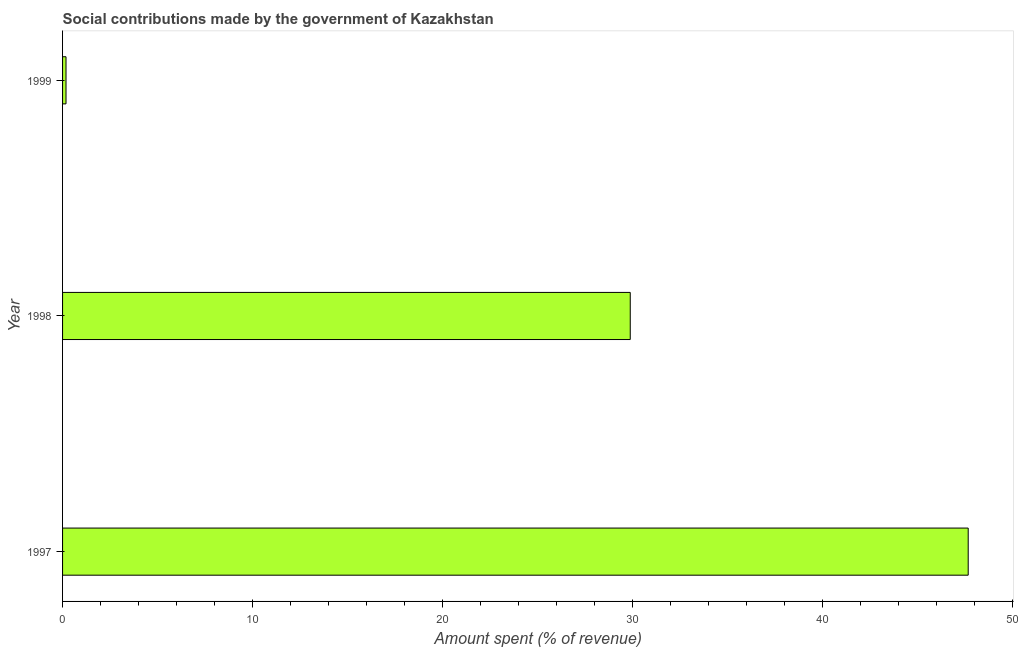Does the graph contain grids?
Make the answer very short. No. What is the title of the graph?
Your response must be concise. Social contributions made by the government of Kazakhstan. What is the label or title of the X-axis?
Ensure brevity in your answer.  Amount spent (% of revenue). What is the amount spent in making social contributions in 1998?
Give a very brief answer. 29.88. Across all years, what is the maximum amount spent in making social contributions?
Your answer should be compact. 47.67. Across all years, what is the minimum amount spent in making social contributions?
Your answer should be very brief. 0.18. In which year was the amount spent in making social contributions maximum?
Your answer should be compact. 1997. In which year was the amount spent in making social contributions minimum?
Give a very brief answer. 1999. What is the sum of the amount spent in making social contributions?
Give a very brief answer. 77.74. What is the difference between the amount spent in making social contributions in 1998 and 1999?
Provide a short and direct response. 29.7. What is the average amount spent in making social contributions per year?
Make the answer very short. 25.91. What is the median amount spent in making social contributions?
Give a very brief answer. 29.88. What is the ratio of the amount spent in making social contributions in 1997 to that in 1999?
Provide a short and direct response. 263.04. Is the amount spent in making social contributions in 1998 less than that in 1999?
Offer a very short reply. No. Is the difference between the amount spent in making social contributions in 1998 and 1999 greater than the difference between any two years?
Offer a terse response. No. What is the difference between the highest and the second highest amount spent in making social contributions?
Make the answer very short. 17.79. What is the difference between the highest and the lowest amount spent in making social contributions?
Your answer should be compact. 47.49. How many bars are there?
Your response must be concise. 3. How many years are there in the graph?
Keep it short and to the point. 3. What is the Amount spent (% of revenue) in 1997?
Give a very brief answer. 47.67. What is the Amount spent (% of revenue) of 1998?
Offer a very short reply. 29.88. What is the Amount spent (% of revenue) of 1999?
Offer a terse response. 0.18. What is the difference between the Amount spent (% of revenue) in 1997 and 1998?
Provide a succinct answer. 17.79. What is the difference between the Amount spent (% of revenue) in 1997 and 1999?
Offer a terse response. 47.49. What is the difference between the Amount spent (% of revenue) in 1998 and 1999?
Your answer should be very brief. 29.7. What is the ratio of the Amount spent (% of revenue) in 1997 to that in 1998?
Ensure brevity in your answer.  1.59. What is the ratio of the Amount spent (% of revenue) in 1997 to that in 1999?
Offer a very short reply. 263.04. What is the ratio of the Amount spent (% of revenue) in 1998 to that in 1999?
Give a very brief answer. 164.88. 